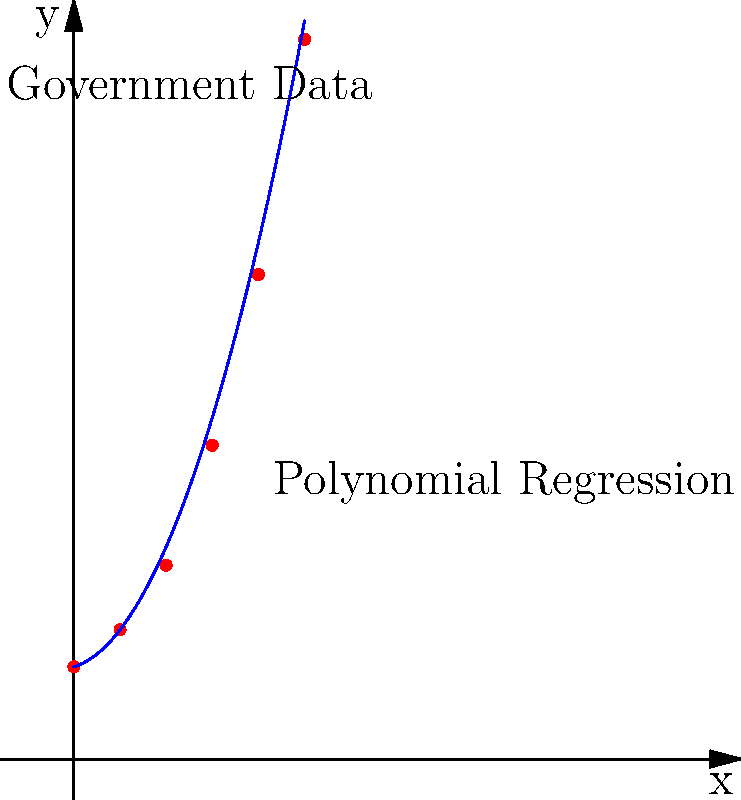You've scraped data from a government website about the growth of a certain economic indicator over 5 years. The data points are plotted in red on the graph. You decide to use polynomial regression to fit a curve to these points. The blue curve represents the polynomial regression. What is the degree of the polynomial used for this regression, and how can you determine this from the graph? To determine the degree of the polynomial used for regression, we need to analyze the shape of the blue curve:

1. Observe the curve: The blue line is not straight, which rules out a linear (1st degree) polynomial.

2. Count inflection points: The curve doesn't have any inflection points (where it changes from concave up to concave down or vice versa).

3. Analyze curvature: The curve is consistently concave up (opens upward) throughout its domain.

4. Compare to known polynomial shapes:
   - Linear (1st degree): Straight line
   - Quadratic (2nd degree): Parabola (one consistent curve)
   - Cubic (3rd degree): S-shaped curve (has an inflection point)
   - Higher degrees: More complex shapes with multiple inflection points

5. Conclusion: The curve most closely resembles a parabola, which is characteristic of a quadratic function.

6. Verify with function: If we had the exact function $f(x) = 2 + 0.3x + 0.5x^2$, we could confirm it's a quadratic polynomial (2nd degree).

Therefore, the polynomial used for this regression is most likely of degree 2 (quadratic).
Answer: Degree 2 (quadratic) 